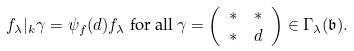<formula> <loc_0><loc_0><loc_500><loc_500>f _ { \lambda } | _ { k } \gamma & = \psi _ { f } ( d ) f _ { \lambda } \ \text {for all} \ \gamma = \left ( \begin{array} { c c } * & * \\ * & d \end{array} \right ) \in \Gamma _ { \lambda } ( { \mathfrak b } ) .</formula> 